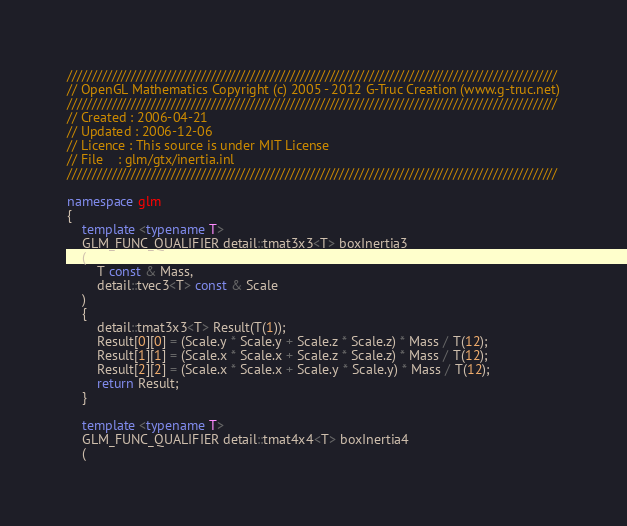<code> <loc_0><loc_0><loc_500><loc_500><_C++_>///////////////////////////////////////////////////////////////////////////////////////////////////
// OpenGL Mathematics Copyright (c) 2005 - 2012 G-Truc Creation (www.g-truc.net)
///////////////////////////////////////////////////////////////////////////////////////////////////
// Created : 2006-04-21
// Updated : 2006-12-06
// Licence : This source is under MIT License
// File    : glm/gtx/inertia.inl
///////////////////////////////////////////////////////////////////////////////////////////////////

namespace glm
{
	template <typename T>
	GLM_FUNC_QUALIFIER detail::tmat3x3<T> boxInertia3
	(
		T const & Mass, 
		detail::tvec3<T> const & Scale
	)
	{
		detail::tmat3x3<T> Result(T(1));
		Result[0][0] = (Scale.y * Scale.y + Scale.z * Scale.z) * Mass / T(12);
		Result[1][1] = (Scale.x * Scale.x + Scale.z * Scale.z) * Mass / T(12);
		Result[2][2] = (Scale.x * Scale.x + Scale.y * Scale.y) * Mass / T(12);
		return Result;
	}

	template <typename T>
	GLM_FUNC_QUALIFIER detail::tmat4x4<T> boxInertia4
	(</code> 